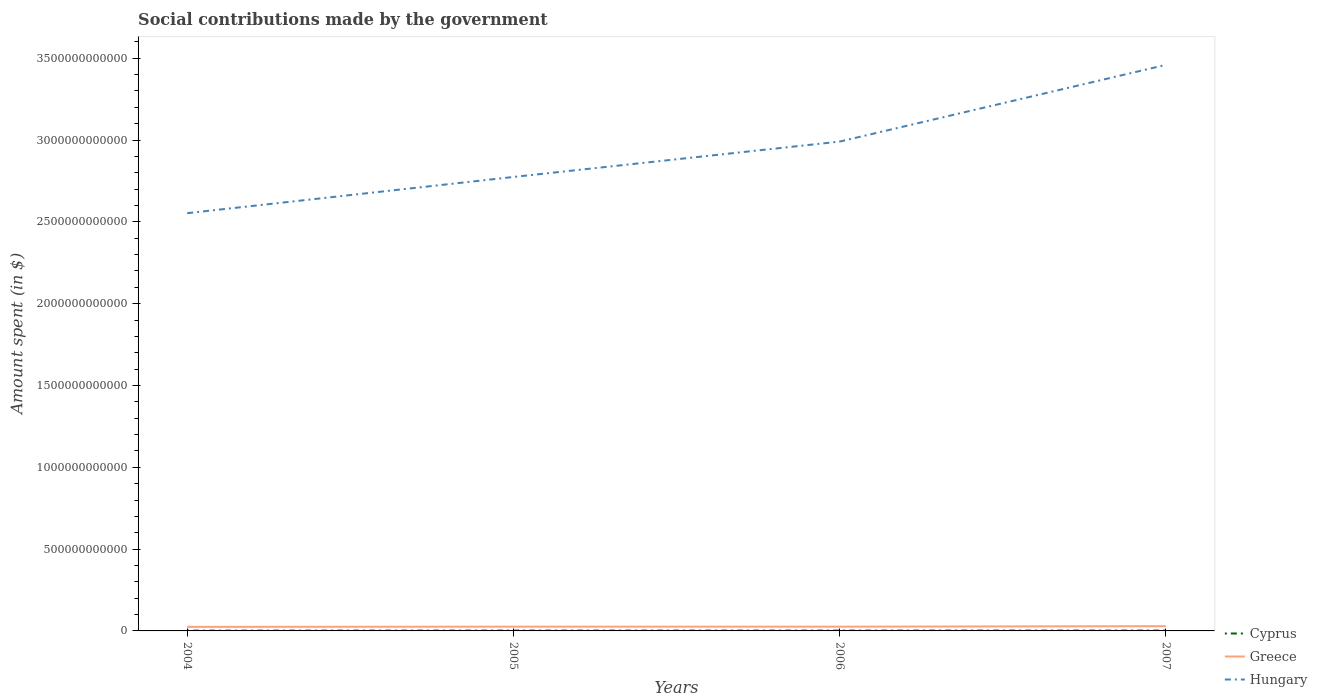How many different coloured lines are there?
Offer a terse response. 3. Across all years, what is the maximum amount spent on social contributions in Cyprus?
Your answer should be very brief. 1.66e+09. What is the total amount spent on social contributions in Hungary in the graph?
Your response must be concise. -2.21e+11. What is the difference between the highest and the second highest amount spent on social contributions in Cyprus?
Give a very brief answer. 3.80e+08. What is the difference between the highest and the lowest amount spent on social contributions in Greece?
Keep it short and to the point. 1. Is the amount spent on social contributions in Hungary strictly greater than the amount spent on social contributions in Greece over the years?
Give a very brief answer. No. How many lines are there?
Keep it short and to the point. 3. What is the difference between two consecutive major ticks on the Y-axis?
Your answer should be very brief. 5.00e+11. Does the graph contain any zero values?
Your response must be concise. No. Does the graph contain grids?
Your answer should be very brief. No. How are the legend labels stacked?
Your answer should be very brief. Vertical. What is the title of the graph?
Offer a terse response. Social contributions made by the government. What is the label or title of the X-axis?
Make the answer very short. Years. What is the label or title of the Y-axis?
Ensure brevity in your answer.  Amount spent (in $). What is the Amount spent (in $) in Cyprus in 2004?
Offer a terse response. 1.66e+09. What is the Amount spent (in $) in Greece in 2004?
Your response must be concise. 2.47e+1. What is the Amount spent (in $) of Hungary in 2004?
Make the answer very short. 2.55e+12. What is the Amount spent (in $) in Cyprus in 2005?
Your answer should be very brief. 1.90e+09. What is the Amount spent (in $) of Greece in 2005?
Your answer should be very brief. 2.61e+1. What is the Amount spent (in $) in Hungary in 2005?
Offer a very short reply. 2.77e+12. What is the Amount spent (in $) of Cyprus in 2006?
Ensure brevity in your answer.  1.93e+09. What is the Amount spent (in $) in Greece in 2006?
Provide a short and direct response. 2.59e+1. What is the Amount spent (in $) of Hungary in 2006?
Your answer should be compact. 2.99e+12. What is the Amount spent (in $) of Cyprus in 2007?
Keep it short and to the point. 2.04e+09. What is the Amount spent (in $) in Greece in 2007?
Ensure brevity in your answer.  2.90e+1. What is the Amount spent (in $) of Hungary in 2007?
Make the answer very short. 3.46e+12. Across all years, what is the maximum Amount spent (in $) of Cyprus?
Offer a very short reply. 2.04e+09. Across all years, what is the maximum Amount spent (in $) of Greece?
Make the answer very short. 2.90e+1. Across all years, what is the maximum Amount spent (in $) in Hungary?
Make the answer very short. 3.46e+12. Across all years, what is the minimum Amount spent (in $) of Cyprus?
Offer a terse response. 1.66e+09. Across all years, what is the minimum Amount spent (in $) in Greece?
Offer a very short reply. 2.47e+1. Across all years, what is the minimum Amount spent (in $) in Hungary?
Keep it short and to the point. 2.55e+12. What is the total Amount spent (in $) in Cyprus in the graph?
Your answer should be compact. 7.53e+09. What is the total Amount spent (in $) in Greece in the graph?
Ensure brevity in your answer.  1.06e+11. What is the total Amount spent (in $) of Hungary in the graph?
Ensure brevity in your answer.  1.18e+13. What is the difference between the Amount spent (in $) in Cyprus in 2004 and that in 2005?
Provide a short and direct response. -2.36e+08. What is the difference between the Amount spent (in $) of Greece in 2004 and that in 2005?
Provide a short and direct response. -1.44e+09. What is the difference between the Amount spent (in $) in Hungary in 2004 and that in 2005?
Give a very brief answer. -2.21e+11. What is the difference between the Amount spent (in $) of Cyprus in 2004 and that in 2006?
Provide a succinct answer. -2.67e+08. What is the difference between the Amount spent (in $) in Greece in 2004 and that in 2006?
Your answer should be compact. -1.27e+09. What is the difference between the Amount spent (in $) of Hungary in 2004 and that in 2006?
Your answer should be compact. -4.38e+11. What is the difference between the Amount spent (in $) of Cyprus in 2004 and that in 2007?
Offer a very short reply. -3.80e+08. What is the difference between the Amount spent (in $) of Greece in 2004 and that in 2007?
Your answer should be very brief. -4.29e+09. What is the difference between the Amount spent (in $) of Hungary in 2004 and that in 2007?
Your response must be concise. -9.06e+11. What is the difference between the Amount spent (in $) in Cyprus in 2005 and that in 2006?
Offer a very short reply. -3.02e+07. What is the difference between the Amount spent (in $) in Greece in 2005 and that in 2006?
Give a very brief answer. 1.61e+08. What is the difference between the Amount spent (in $) of Hungary in 2005 and that in 2006?
Provide a succinct answer. -2.16e+11. What is the difference between the Amount spent (in $) in Cyprus in 2005 and that in 2007?
Provide a succinct answer. -1.44e+08. What is the difference between the Amount spent (in $) of Greece in 2005 and that in 2007?
Your answer should be very brief. -2.86e+09. What is the difference between the Amount spent (in $) in Hungary in 2005 and that in 2007?
Your response must be concise. -6.85e+11. What is the difference between the Amount spent (in $) of Cyprus in 2006 and that in 2007?
Provide a succinct answer. -1.13e+08. What is the difference between the Amount spent (in $) of Greece in 2006 and that in 2007?
Keep it short and to the point. -3.02e+09. What is the difference between the Amount spent (in $) of Hungary in 2006 and that in 2007?
Keep it short and to the point. -4.69e+11. What is the difference between the Amount spent (in $) of Cyprus in 2004 and the Amount spent (in $) of Greece in 2005?
Keep it short and to the point. -2.44e+1. What is the difference between the Amount spent (in $) of Cyprus in 2004 and the Amount spent (in $) of Hungary in 2005?
Offer a terse response. -2.77e+12. What is the difference between the Amount spent (in $) of Greece in 2004 and the Amount spent (in $) of Hungary in 2005?
Make the answer very short. -2.75e+12. What is the difference between the Amount spent (in $) of Cyprus in 2004 and the Amount spent (in $) of Greece in 2006?
Ensure brevity in your answer.  -2.43e+1. What is the difference between the Amount spent (in $) of Cyprus in 2004 and the Amount spent (in $) of Hungary in 2006?
Provide a short and direct response. -2.99e+12. What is the difference between the Amount spent (in $) in Greece in 2004 and the Amount spent (in $) in Hungary in 2006?
Give a very brief answer. -2.97e+12. What is the difference between the Amount spent (in $) of Cyprus in 2004 and the Amount spent (in $) of Greece in 2007?
Give a very brief answer. -2.73e+1. What is the difference between the Amount spent (in $) of Cyprus in 2004 and the Amount spent (in $) of Hungary in 2007?
Provide a succinct answer. -3.46e+12. What is the difference between the Amount spent (in $) of Greece in 2004 and the Amount spent (in $) of Hungary in 2007?
Your answer should be very brief. -3.44e+12. What is the difference between the Amount spent (in $) in Cyprus in 2005 and the Amount spent (in $) in Greece in 2006?
Provide a short and direct response. -2.40e+1. What is the difference between the Amount spent (in $) of Cyprus in 2005 and the Amount spent (in $) of Hungary in 2006?
Your answer should be compact. -2.99e+12. What is the difference between the Amount spent (in $) of Greece in 2005 and the Amount spent (in $) of Hungary in 2006?
Your answer should be very brief. -2.96e+12. What is the difference between the Amount spent (in $) in Cyprus in 2005 and the Amount spent (in $) in Greece in 2007?
Make the answer very short. -2.71e+1. What is the difference between the Amount spent (in $) in Cyprus in 2005 and the Amount spent (in $) in Hungary in 2007?
Your answer should be compact. -3.46e+12. What is the difference between the Amount spent (in $) of Greece in 2005 and the Amount spent (in $) of Hungary in 2007?
Your answer should be compact. -3.43e+12. What is the difference between the Amount spent (in $) in Cyprus in 2006 and the Amount spent (in $) in Greece in 2007?
Keep it short and to the point. -2.70e+1. What is the difference between the Amount spent (in $) of Cyprus in 2006 and the Amount spent (in $) of Hungary in 2007?
Keep it short and to the point. -3.46e+12. What is the difference between the Amount spent (in $) of Greece in 2006 and the Amount spent (in $) of Hungary in 2007?
Make the answer very short. -3.43e+12. What is the average Amount spent (in $) in Cyprus per year?
Offer a very short reply. 1.88e+09. What is the average Amount spent (in $) of Greece per year?
Your answer should be compact. 2.64e+1. What is the average Amount spent (in $) of Hungary per year?
Offer a terse response. 2.94e+12. In the year 2004, what is the difference between the Amount spent (in $) in Cyprus and Amount spent (in $) in Greece?
Keep it short and to the point. -2.30e+1. In the year 2004, what is the difference between the Amount spent (in $) in Cyprus and Amount spent (in $) in Hungary?
Offer a terse response. -2.55e+12. In the year 2004, what is the difference between the Amount spent (in $) of Greece and Amount spent (in $) of Hungary?
Your answer should be compact. -2.53e+12. In the year 2005, what is the difference between the Amount spent (in $) of Cyprus and Amount spent (in $) of Greece?
Your response must be concise. -2.42e+1. In the year 2005, what is the difference between the Amount spent (in $) of Cyprus and Amount spent (in $) of Hungary?
Make the answer very short. -2.77e+12. In the year 2005, what is the difference between the Amount spent (in $) of Greece and Amount spent (in $) of Hungary?
Make the answer very short. -2.75e+12. In the year 2006, what is the difference between the Amount spent (in $) in Cyprus and Amount spent (in $) in Greece?
Offer a terse response. -2.40e+1. In the year 2006, what is the difference between the Amount spent (in $) in Cyprus and Amount spent (in $) in Hungary?
Provide a short and direct response. -2.99e+12. In the year 2006, what is the difference between the Amount spent (in $) of Greece and Amount spent (in $) of Hungary?
Your response must be concise. -2.96e+12. In the year 2007, what is the difference between the Amount spent (in $) of Cyprus and Amount spent (in $) of Greece?
Keep it short and to the point. -2.69e+1. In the year 2007, what is the difference between the Amount spent (in $) of Cyprus and Amount spent (in $) of Hungary?
Your answer should be compact. -3.46e+12. In the year 2007, what is the difference between the Amount spent (in $) of Greece and Amount spent (in $) of Hungary?
Your response must be concise. -3.43e+12. What is the ratio of the Amount spent (in $) of Cyprus in 2004 to that in 2005?
Provide a short and direct response. 0.88. What is the ratio of the Amount spent (in $) in Greece in 2004 to that in 2005?
Offer a terse response. 0.94. What is the ratio of the Amount spent (in $) of Hungary in 2004 to that in 2005?
Your response must be concise. 0.92. What is the ratio of the Amount spent (in $) of Cyprus in 2004 to that in 2006?
Your answer should be very brief. 0.86. What is the ratio of the Amount spent (in $) in Greece in 2004 to that in 2006?
Provide a short and direct response. 0.95. What is the ratio of the Amount spent (in $) in Hungary in 2004 to that in 2006?
Your answer should be compact. 0.85. What is the ratio of the Amount spent (in $) of Cyprus in 2004 to that in 2007?
Offer a terse response. 0.81. What is the ratio of the Amount spent (in $) of Greece in 2004 to that in 2007?
Offer a very short reply. 0.85. What is the ratio of the Amount spent (in $) in Hungary in 2004 to that in 2007?
Ensure brevity in your answer.  0.74. What is the ratio of the Amount spent (in $) in Cyprus in 2005 to that in 2006?
Make the answer very short. 0.98. What is the ratio of the Amount spent (in $) in Hungary in 2005 to that in 2006?
Provide a succinct answer. 0.93. What is the ratio of the Amount spent (in $) of Cyprus in 2005 to that in 2007?
Provide a short and direct response. 0.93. What is the ratio of the Amount spent (in $) of Greece in 2005 to that in 2007?
Give a very brief answer. 0.9. What is the ratio of the Amount spent (in $) in Hungary in 2005 to that in 2007?
Give a very brief answer. 0.8. What is the ratio of the Amount spent (in $) of Cyprus in 2006 to that in 2007?
Keep it short and to the point. 0.94. What is the ratio of the Amount spent (in $) of Greece in 2006 to that in 2007?
Provide a succinct answer. 0.9. What is the ratio of the Amount spent (in $) of Hungary in 2006 to that in 2007?
Provide a succinct answer. 0.86. What is the difference between the highest and the second highest Amount spent (in $) of Cyprus?
Your answer should be very brief. 1.13e+08. What is the difference between the highest and the second highest Amount spent (in $) in Greece?
Offer a very short reply. 2.86e+09. What is the difference between the highest and the second highest Amount spent (in $) of Hungary?
Offer a very short reply. 4.69e+11. What is the difference between the highest and the lowest Amount spent (in $) of Cyprus?
Your response must be concise. 3.80e+08. What is the difference between the highest and the lowest Amount spent (in $) in Greece?
Your response must be concise. 4.29e+09. What is the difference between the highest and the lowest Amount spent (in $) of Hungary?
Offer a very short reply. 9.06e+11. 